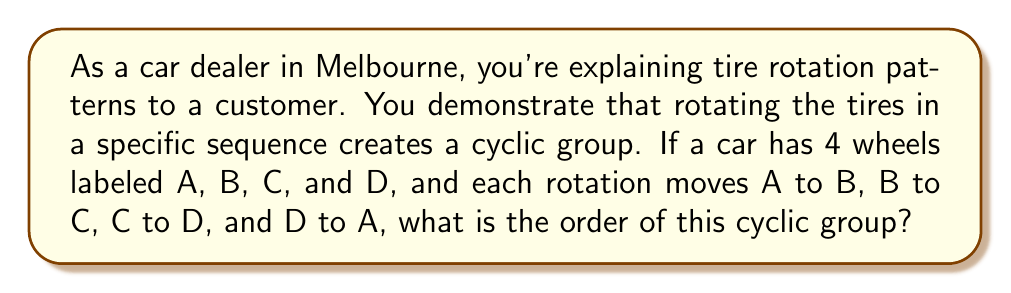What is the answer to this math problem? Let's approach this step-by-step:

1) First, let's define our group operation. In this case, it's the rotation of tires in the sequence A → B → C → D → A.

2) Let's call this rotation R. So, R(A) = B, R(B) = C, R(C) = D, and R(D) = A.

3) Now, let's see what happens when we apply this rotation multiple times:

   R¹ = (A B C D)
   R² = (A C)(B D)
   R³ = (A D C B)
   R⁴ = (A)(B)(C)(D) = identity

4) We can see that after applying R four times, we get back to the original configuration. This means that R⁴ = e, where e is the identity element.

5) In cyclic group theory, the order of an element is the smallest positive integer n such that a^n = e, where a is the group element and e is the identity.

6) Since R⁴ = e, and this is the smallest positive integer power of R that equals the identity, the order of R is 4.

7) In a cyclic group generated by a single element, the order of the group is equal to the order of the generating element.

Therefore, the order of the cyclic group representing this tire rotation pattern is 4.
Answer: The order of the cyclic group is 4. 